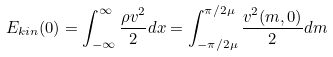Convert formula to latex. <formula><loc_0><loc_0><loc_500><loc_500>E _ { k i n } ( 0 ) = \int _ { - \infty } ^ { \infty } \frac { \rho v ^ { 2 } } { 2 } d x = \int _ { - \pi / 2 \mu } ^ { \pi / 2 \mu } \frac { v ^ { 2 } ( m , 0 ) } { 2 } d m</formula> 